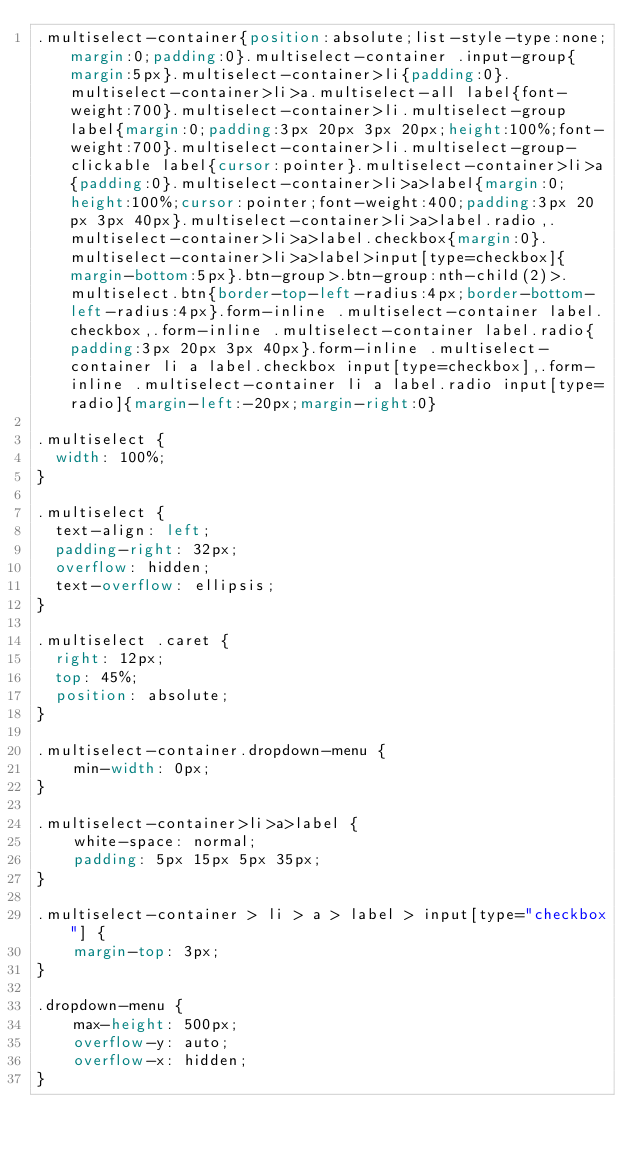<code> <loc_0><loc_0><loc_500><loc_500><_CSS_>.multiselect-container{position:absolute;list-style-type:none;margin:0;padding:0}.multiselect-container .input-group{margin:5px}.multiselect-container>li{padding:0}.multiselect-container>li>a.multiselect-all label{font-weight:700}.multiselect-container>li.multiselect-group label{margin:0;padding:3px 20px 3px 20px;height:100%;font-weight:700}.multiselect-container>li.multiselect-group-clickable label{cursor:pointer}.multiselect-container>li>a{padding:0}.multiselect-container>li>a>label{margin:0;height:100%;cursor:pointer;font-weight:400;padding:3px 20px 3px 40px}.multiselect-container>li>a>label.radio,.multiselect-container>li>a>label.checkbox{margin:0}.multiselect-container>li>a>label>input[type=checkbox]{margin-bottom:5px}.btn-group>.btn-group:nth-child(2)>.multiselect.btn{border-top-left-radius:4px;border-bottom-left-radius:4px}.form-inline .multiselect-container label.checkbox,.form-inline .multiselect-container label.radio{padding:3px 20px 3px 40px}.form-inline .multiselect-container li a label.checkbox input[type=checkbox],.form-inline .multiselect-container li a label.radio input[type=radio]{margin-left:-20px;margin-right:0}

.multiselect {
  width: 100%;
}

.multiselect {
  text-align: left;
  padding-right: 32px;
  overflow: hidden;
  text-overflow: ellipsis;
}

.multiselect .caret {
  right: 12px;
  top: 45%;
  position: absolute;
}

.multiselect-container.dropdown-menu {
    min-width: 0px;
}

.multiselect-container>li>a>label {
    white-space: normal;
    padding: 5px 15px 5px 35px;
}

.multiselect-container > li > a > label > input[type="checkbox"] {
    margin-top: 3px;
}

.dropdown-menu {
	max-height: 500px;
	overflow-y: auto;
	overflow-x: hidden;
}</code> 